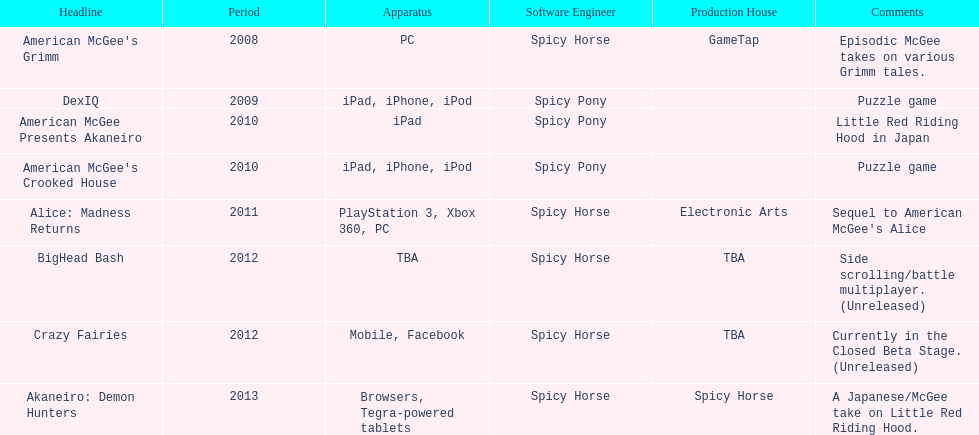What was the only game published by electronic arts? Alice: Madness Returns. 